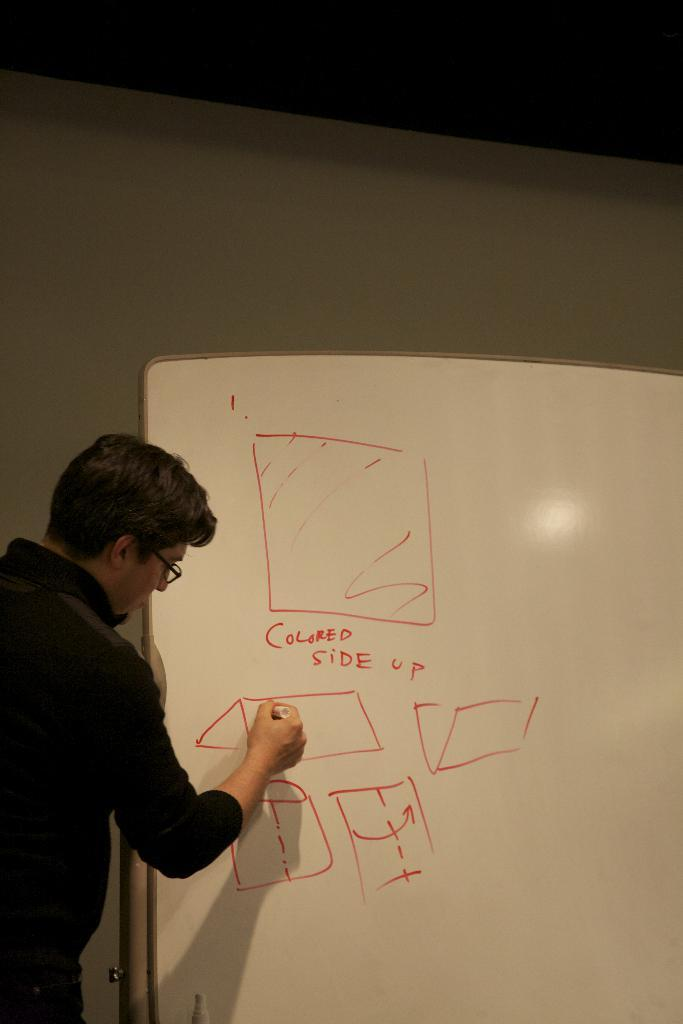<image>
Relay a brief, clear account of the picture shown. a person drawing on a board and saying colored side up 